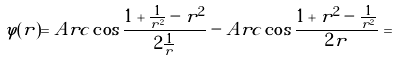<formula> <loc_0><loc_0><loc_500><loc_500>\varphi ( r ) = A r c \cos \frac { 1 + \frac { 1 } { r ^ { 2 } } - r ^ { 2 } } { 2 \frac { 1 } { r } } - A r c \cos \frac { 1 + r ^ { 2 } - \frac { 1 } { r ^ { 2 } } } { 2 r } =</formula> 